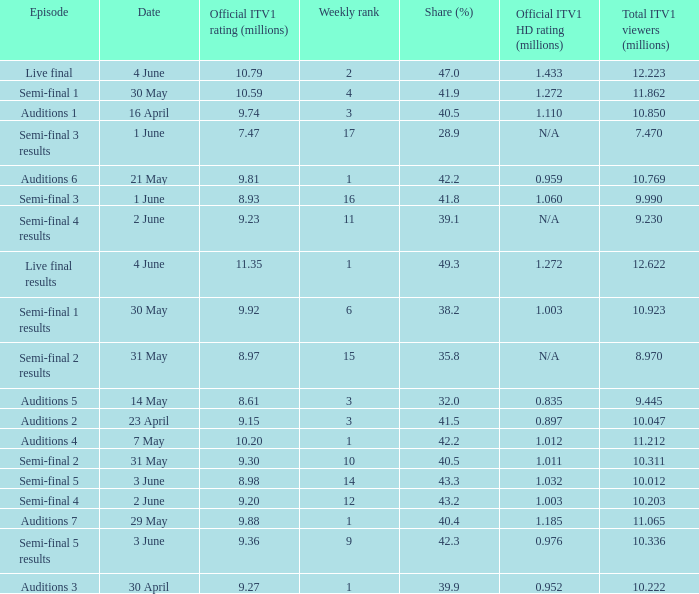When was the episode that had a share (%) of 41.5? 23 April. 